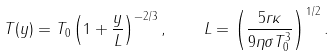<formula> <loc_0><loc_0><loc_500><loc_500>T ( y ) = T _ { 0 } \left ( 1 + \frac { y } { L } \right ) ^ { - 2 / 3 } , \quad L = \left ( \frac { 5 r \kappa } { 9 \eta \sigma T _ { 0 } ^ { 3 } } \right ) ^ { 1 / 2 } .</formula> 